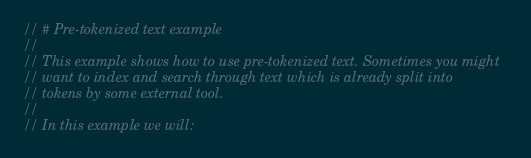Convert code to text. <code><loc_0><loc_0><loc_500><loc_500><_Rust_>// # Pre-tokenized text example
//
// This example shows how to use pre-tokenized text. Sometimes you might
// want to index and search through text which is already split into
// tokens by some external tool.
//
// In this example we will:</code> 